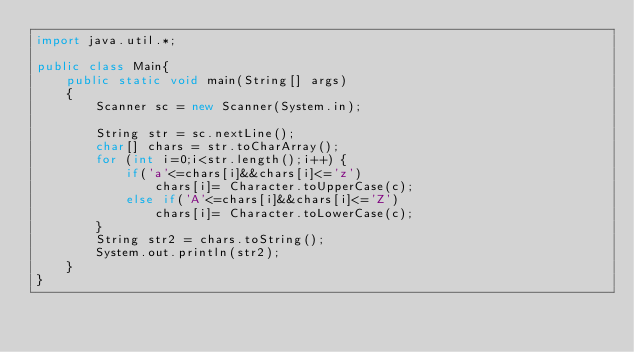Convert code to text. <code><loc_0><loc_0><loc_500><loc_500><_Java_>import java.util.*;

public class Main{      
    public static void main(String[] args)
    {
        Scanner sc = new Scanner(System.in);
        
        String str = sc.nextLine();
        char[] chars = str.toCharArray();
        for (int i=0;i<str.length();i++) {
            if('a'<=chars[i]&&chars[i]<='z')
                chars[i]= Character.toUpperCase(c);
            else if('A'<=chars[i]&&chars[i]<='Z')
                chars[i]= Character.toLowerCase(c);
        }
        String str2 = chars.toString();
        System.out.println(str2);
    }
}

</code> 